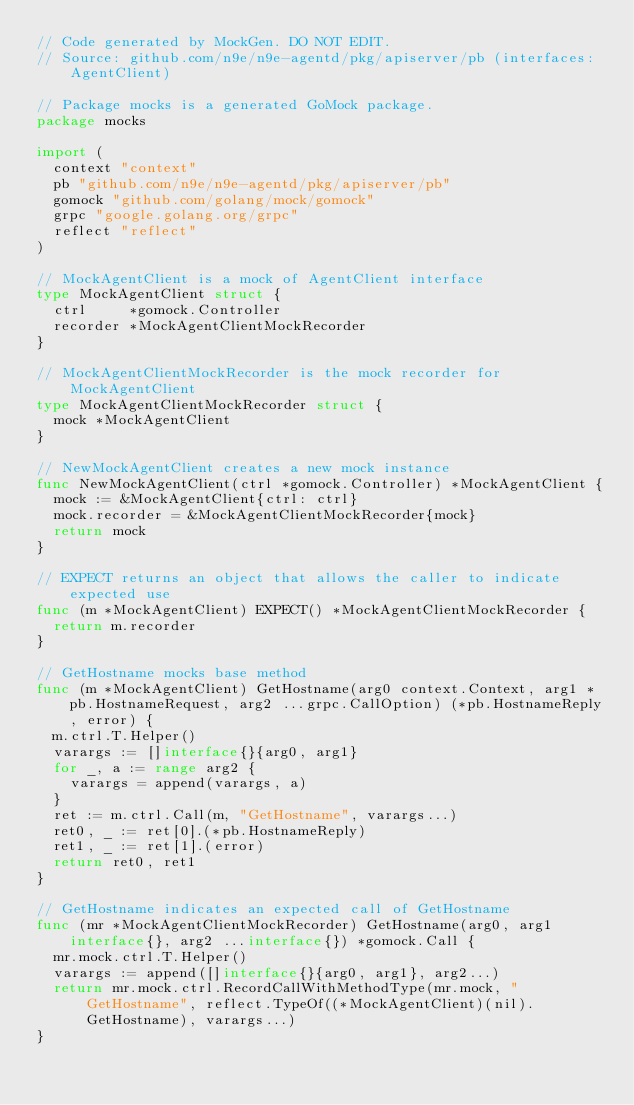Convert code to text. <code><loc_0><loc_0><loc_500><loc_500><_Go_>// Code generated by MockGen. DO NOT EDIT.
// Source: github.com/n9e/n9e-agentd/pkg/apiserver/pb (interfaces: AgentClient)

// Package mocks is a generated GoMock package.
package mocks

import (
	context "context"
	pb "github.com/n9e/n9e-agentd/pkg/apiserver/pb"
	gomock "github.com/golang/mock/gomock"
	grpc "google.golang.org/grpc"
	reflect "reflect"
)

// MockAgentClient is a mock of AgentClient interface
type MockAgentClient struct {
	ctrl     *gomock.Controller
	recorder *MockAgentClientMockRecorder
}

// MockAgentClientMockRecorder is the mock recorder for MockAgentClient
type MockAgentClientMockRecorder struct {
	mock *MockAgentClient
}

// NewMockAgentClient creates a new mock instance
func NewMockAgentClient(ctrl *gomock.Controller) *MockAgentClient {
	mock := &MockAgentClient{ctrl: ctrl}
	mock.recorder = &MockAgentClientMockRecorder{mock}
	return mock
}

// EXPECT returns an object that allows the caller to indicate expected use
func (m *MockAgentClient) EXPECT() *MockAgentClientMockRecorder {
	return m.recorder
}

// GetHostname mocks base method
func (m *MockAgentClient) GetHostname(arg0 context.Context, arg1 *pb.HostnameRequest, arg2 ...grpc.CallOption) (*pb.HostnameReply, error) {
	m.ctrl.T.Helper()
	varargs := []interface{}{arg0, arg1}
	for _, a := range arg2 {
		varargs = append(varargs, a)
	}
	ret := m.ctrl.Call(m, "GetHostname", varargs...)
	ret0, _ := ret[0].(*pb.HostnameReply)
	ret1, _ := ret[1].(error)
	return ret0, ret1
}

// GetHostname indicates an expected call of GetHostname
func (mr *MockAgentClientMockRecorder) GetHostname(arg0, arg1 interface{}, arg2 ...interface{}) *gomock.Call {
	mr.mock.ctrl.T.Helper()
	varargs := append([]interface{}{arg0, arg1}, arg2...)
	return mr.mock.ctrl.RecordCallWithMethodType(mr.mock, "GetHostname", reflect.TypeOf((*MockAgentClient)(nil).GetHostname), varargs...)
}
</code> 